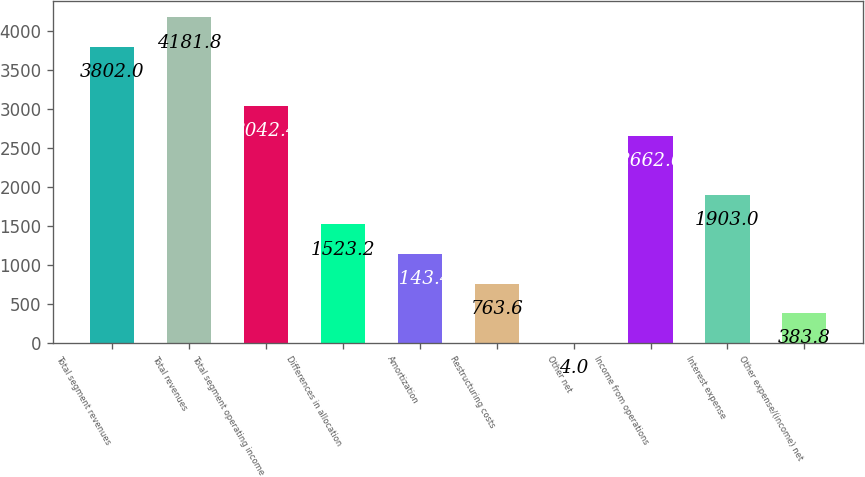Convert chart to OTSL. <chart><loc_0><loc_0><loc_500><loc_500><bar_chart><fcel>Total segment revenues<fcel>Total revenues<fcel>Total segment operating income<fcel>Differences in allocation<fcel>Amortization<fcel>Restructuring costs<fcel>Other net<fcel>Income from operations<fcel>Interest expense<fcel>Other expense/(income) net<nl><fcel>3802<fcel>4181.8<fcel>3042.4<fcel>1523.2<fcel>1143.4<fcel>763.6<fcel>4<fcel>2662.6<fcel>1903<fcel>383.8<nl></chart> 